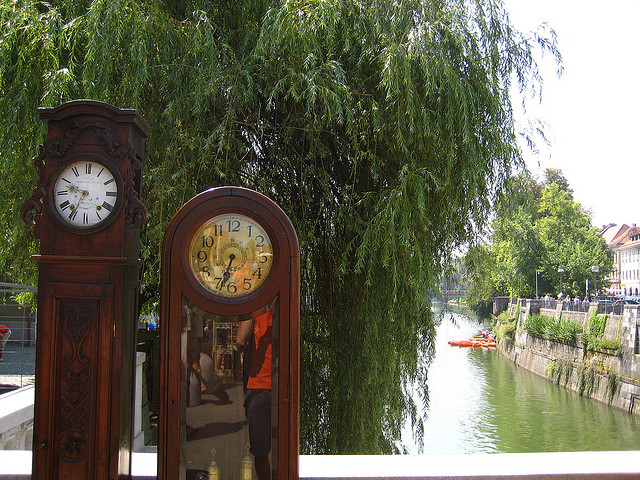<image>What times do the clocks say? It's ambiguous what times the clocks say. They could possibly read '6:34 and 9:34', '6:33 and 9:35' or others. What times do the clocks say? I am not sure what times do the clocks say. It can be seen '6:33', '6:34', '6:35', '9:35', '9:36' or '6:36'. 